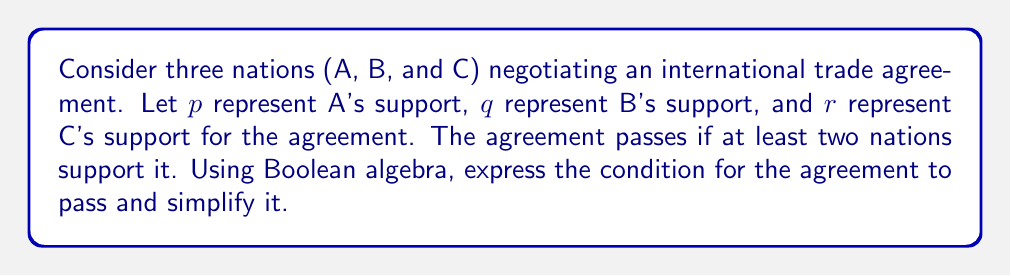Can you solve this math problem? Let's approach this step-by-step:

1) First, we need to express the condition for the agreement to pass. It passes if:
   - A and B support it, OR
   - A and C support it, OR
   - B and C support it

2) We can express this in Boolean algebra as:
   $$(p \land q) \lor (p \land r) \lor (q \land r)$$

3) This expression can be simplified using the distributive law of Boolean algebra:
   $$(p \land q) \lor (p \land r) \lor (q \land r)$$
   $$= p \land (q \lor r) \lor (q \land r)$$

4) Using the absorption law $(A \lor (A \land B) = A)$, we can further simplify:
   $$p \land (q \lor r) \lor (q \land r)$$
   $$= (p \land (q \lor r)) \lor (q \land r)$$
   $$= (p \lor q) \land (p \lor r) \land (q \lor r)$$

5) This final expression represents the simplified condition for the agreement to pass.

As the Model UN president, you could use this to analyze how different combinations of national interests affect the outcome of the agreement, and strategize accordingly.
Answer: $(p \lor q) \land (p \lor r) \land (q \lor r)$ 